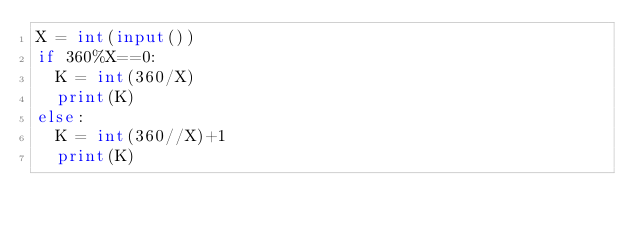<code> <loc_0><loc_0><loc_500><loc_500><_Python_>X = int(input())
if 360%X==0:
  K = int(360/X)
  print(K)
else:
  K = int(360//X)+1
  print(K)</code> 